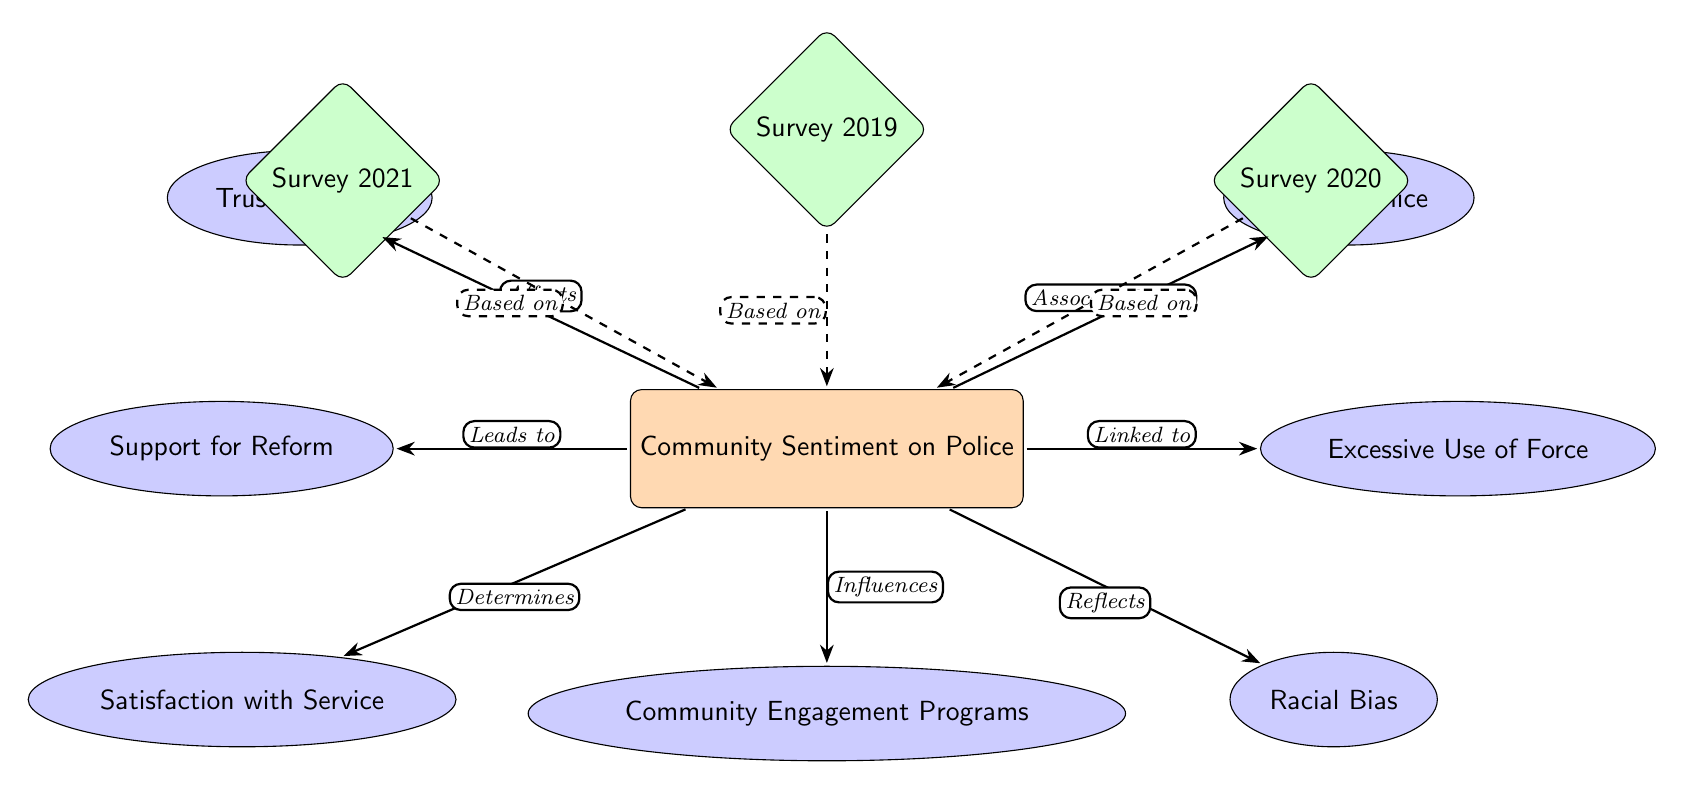What are the six factors affecting community sentiment on police? The diagram lists six factors connected to the main node "Community Sentiment on Police". Reading from the diagram, these factors are "Trust in Police", "Support for Reform", "Satisfaction with Service", "Fear of Police", "Excessive Use of Force", and "Racial Bias".
Answer: Trust in Police, Support for Reform, Satisfaction with Service, Fear of Police, Excessive Use of Force, Racial Bias Which survey year is associated with the factors influencing community sentiment? The diagram includes three survey nodes labeled as Survey 2019, Survey 2020, and Survey 2021. These nodes are connected to the main node "Community Sentiment on Police", indicating their relevance.
Answer: Survey 2019, Survey 2020, Survey 2021 How many influences can be seen from the main sentiment node? From the main node "Community Sentiment on Police", there are six arrows pointing to the factors, indicating six influences on the sentiment. Each factor is connected through a directed edge.
Answer: Six What is the relationship between community engagement programs and community sentiment? The arrow from "Community Engagement Programs" to "Community Sentiment on Police" indicates that community engagement programs influence the sentiment. This is shown by the label on the arrow.
Answer: Influences Which factor is linked to excessive use of force? The diagram shows a directed relationship from the main node to the factor labeled "Excessive Use of Force", indicating a link. The term "Linked to" is present on the corresponding arrow.
Answer: Linked to What does the dashed arrow indicate between surveys and community sentiment? The dashed arrows connecting the survey nodes to the main sentiment node signify that the survey data is based on community sentiment. The phrases along the arrow confirm that these surveys inform understanding.
Answer: Based on Which factor reflects the community sentiment? The diagram illustrates that "Racial Bias" reflects the community sentiment as indicated by the arrow labeled "Reflects" leading from "Racial Bias" to the main sentiment node.
Answer: Reflects How many factors are associated with fear of police? The diagram has a single arrow going from "Fear of Police" to the main sentiment, indicating that "Fear of Police" is just one of the factors influencing the sentiment. Therefore, the count is one.
Answer: One 